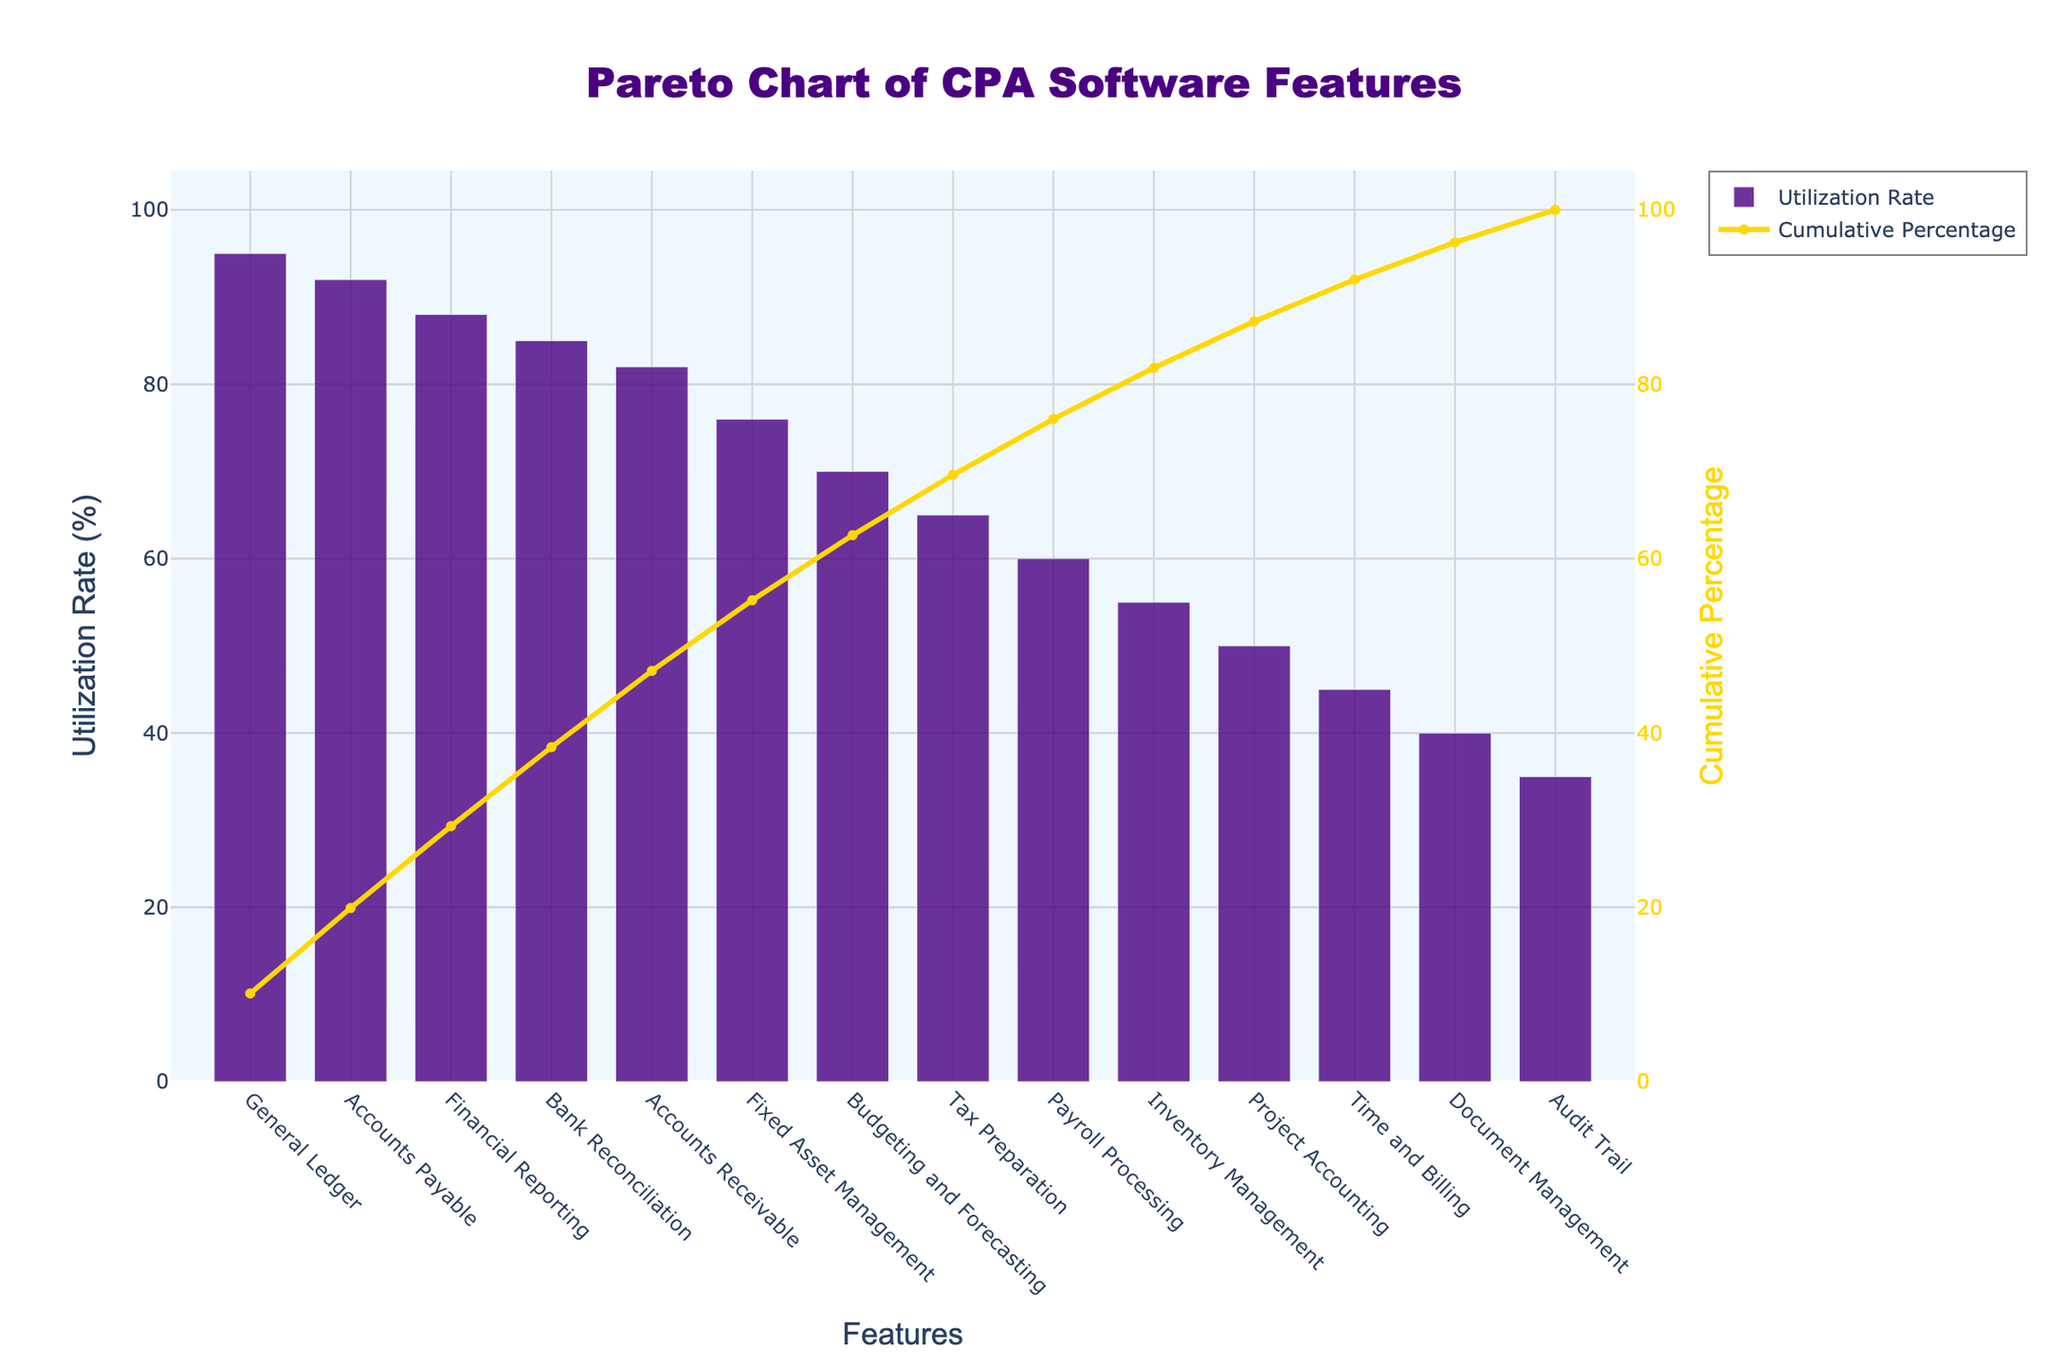What is the title of the chart? The title of the chart is typically displayed at the top, summarizing the content of the figure. In this case, the title is "Pareto Chart of CPA Software Features".
Answer: Pareto Chart of CPA Software Features What feature has the highest utilization rate? To answer this, look at the tallest bar on the chart, which represents the feature with the highest utilization rate.
Answer: General Ledger What is the utilization rate for Financial Reporting? Find the bar labeled "Financial Reporting" and read the value on the y-axis corresponding to its height.
Answer: 88% How many features have a utilization rate above 80%? Count the number of bars that extend above the 80% mark on the y-axis.
Answer: 5 What is the cumulative percentage for Accounts Receivable? Look at the cumulative percentage line corresponding to the "Accounts Receivable" bar and read the value on the y-axis on the right side.
Answer: Approximately 72% Which feature is used more: Payroll Processing or Inventory Management? Compare the heights of the bars for "Payroll Processing" and "Inventory Management". The taller bar indicates the more used feature.
Answer: Payroll Processing What are the two least utilized features, and what are their utilization rates? Identify the two shortest bars and read their corresponding utilization rates from the y-axis.
Answer: Audit Trail (35%) and Document Management (40%) At which feature does the cumulative percentage exceed 50%? Trace the cumulative percentage line until it crosses the 50% mark on the y-axis and identify the corresponding feature.
Answer: Accounts Payable What is the approximate difference in utilization rates between the top two features? Find the utilization rates of the top two features and subtract the lower rate from the higher rate.
Answer: 3% Which features contribute to the first 25% of the cumulative percentage? Find the point where the cumulative percentage first exceeds 25% and identify the features contributing to this sum.
Answer: General Ledger and Accounts Payable 